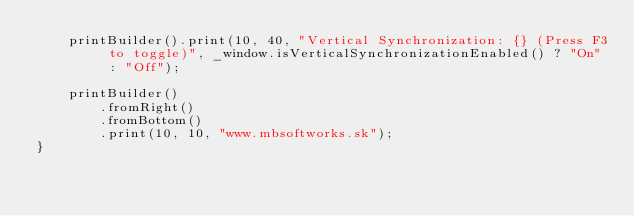Convert code to text. <code><loc_0><loc_0><loc_500><loc_500><_C++_>    printBuilder().print(10, 40, "Vertical Synchronization: {} (Press F3 to toggle)", _window.isVerticalSynchronizationEnabled() ? "On" : "Off");

    printBuilder()
        .fromRight()
        .fromBottom()
        .print(10, 10, "www.mbsoftworks.sk");
}
</code> 